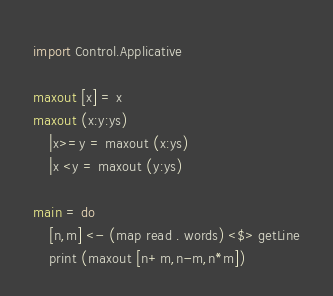<code> <loc_0><loc_0><loc_500><loc_500><_Haskell_>import Control.Applicative

maxout [x] = x
maxout (x:y:ys)
    |x>=y = maxout (x:ys)
    |x <y = maxout (y:ys)

main = do
    [n,m] <- (map read . words) <$> getLine
    print (maxout [n+m,n-m,n*m])</code> 